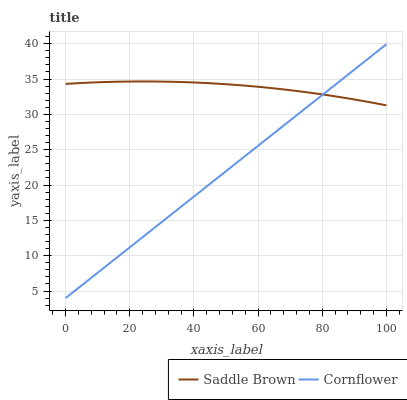Does Cornflower have the minimum area under the curve?
Answer yes or no. Yes. Does Saddle Brown have the maximum area under the curve?
Answer yes or no. Yes. Does Saddle Brown have the minimum area under the curve?
Answer yes or no. No. Is Cornflower the smoothest?
Answer yes or no. Yes. Is Saddle Brown the roughest?
Answer yes or no. Yes. Is Saddle Brown the smoothest?
Answer yes or no. No. Does Cornflower have the lowest value?
Answer yes or no. Yes. Does Saddle Brown have the lowest value?
Answer yes or no. No. Does Cornflower have the highest value?
Answer yes or no. Yes. Does Saddle Brown have the highest value?
Answer yes or no. No. Does Cornflower intersect Saddle Brown?
Answer yes or no. Yes. Is Cornflower less than Saddle Brown?
Answer yes or no. No. Is Cornflower greater than Saddle Brown?
Answer yes or no. No. 